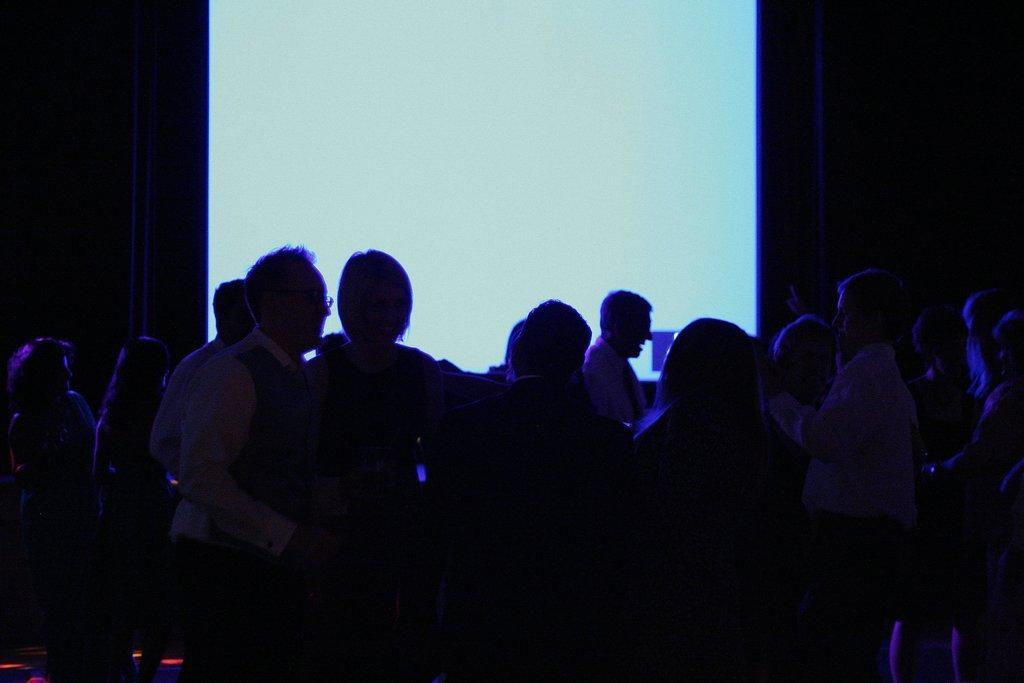In one or two sentences, can you explain what this image depicts? In this image I can see the dark picture in which I can see number of persons standing. In the background I can see the screen and the dark background. 